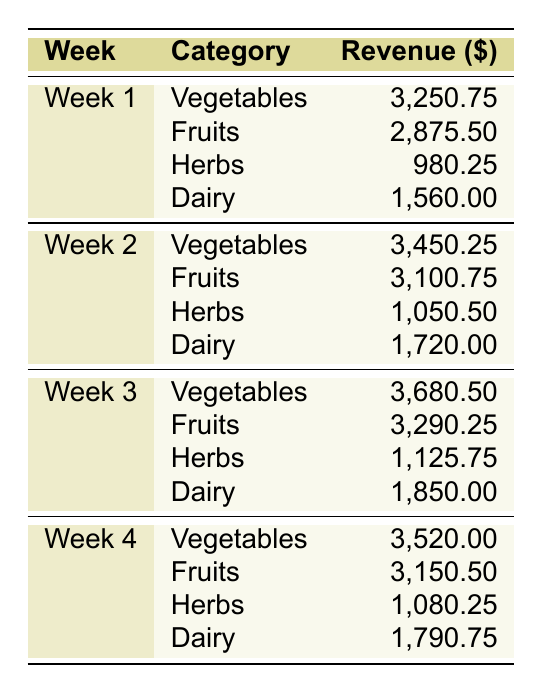What was the total revenue for Week 1? To find the total revenue for Week 1, sum the revenues for all categories: 3,250.75 + 2,875.50 + 980.25 + 1,560.00 = 8,666.50.
Answer: 8,666.50 Which category had the highest revenue in Week 3? In Week 3, compare the revenues for all categories: Vegetables (3,680.50), Fruits (3,290.25), Herbs (1,125.75), Dairy (1,850.00). The highest is 3,680.50 from Vegetables.
Answer: Vegetables What is the average revenue for Fruits across all weeks? Add all Fruits revenues: 2,875.50 (Week 1) + 3,100.75 (Week 2) + 3,290.25 (Week 3) + 3,150.50 (Week 4) = 12,417.00. There are 4 weeks, so the average is 12,417.00 / 4 = 3,104.25.
Answer: 3,104.25 Is the revenue from Dairy in Week 2 greater than the revenue from Herbs in Week 4? The revenue for Dairy in Week 2 is 1,720.00, and for Herbs in Week 4 is 1,080.25. Since 1,720.00 is greater than 1,080.25, the statement is true.
Answer: Yes Which week saw a revenue increase for Vegetables compared to the previous week? Compare Vegetable revenues week by week: Week 1 is 3,250.75, Week 2 is 3,450.25 (increase), Week 3 is 3,680.50 (increase), and Week 4 is 3,520.00 (decrease). The weeks with increases are Week 2 and Week 3.
Answer: Weeks 2 and 3 What was the difference in revenue between Dairy in Week 1 and Week 4? Revenue for Dairy in Week 1 is 1,560.00, and in Week 4 is 1,790.75. Calculate the difference: 1,790.75 - 1,560.00 = 230.75.
Answer: 230.75 Did total revenues increase or decrease from Week 1 to Week 4? Calculate the total for Week 1: 8,666.50 and for Week 4: 3,520.00 + 3,150.50 + 1,080.25 + 1,790.75 = 9,541.00. Since 9,541.00 is greater than 8,666.50, total revenues increased.
Answer: Increased Which produce category consistently generated the most revenue every week? Evaluate the weekly revenues: for Vegetables (3,250.75, 3,450.25, 3,680.50, 3,520.00), for Fruits (2,875.50, 3,100.75, 3,290.25, 3,150.50); Vegetables has the highest revenue every week.
Answer: Vegetables What was the total revenue across all categories for Week 2? Sum up all categories for Week 2: 3,450.25 (Vegetables) + 3,100.75 (Fruits) + 1,050.50 (Herbs) + 1,720.00 (Dairy) = 9,321.50.
Answer: 9,321.50 